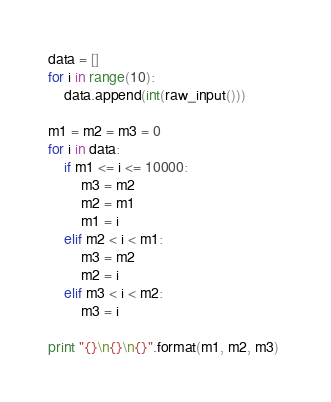<code> <loc_0><loc_0><loc_500><loc_500><_Python_>data = []
for i in range(10):
    data.append(int(raw_input()))

m1 = m2 = m3 = 0 
for i in data:
    if m1 <= i <= 10000:
        m3 = m2
        m2 = m1
        m1 = i 
    elif m2 < i < m1: 
        m3 = m2
        m2 = i 
    elif m3 < i < m2: 
        m3 = i 

print "{}\n{}\n{}".format(m1, m2, m3) </code> 